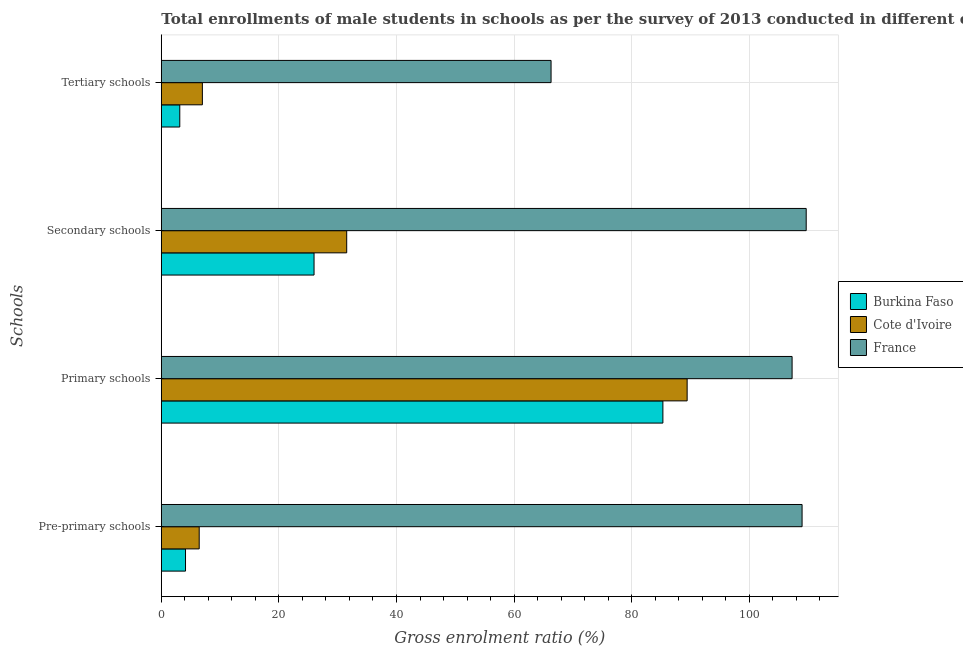Are the number of bars per tick equal to the number of legend labels?
Your answer should be compact. Yes. How many bars are there on the 3rd tick from the top?
Ensure brevity in your answer.  3. How many bars are there on the 2nd tick from the bottom?
Provide a succinct answer. 3. What is the label of the 1st group of bars from the top?
Provide a short and direct response. Tertiary schools. What is the gross enrolment ratio(male) in primary schools in France?
Keep it short and to the point. 107.29. Across all countries, what is the maximum gross enrolment ratio(male) in pre-primary schools?
Provide a short and direct response. 108.99. Across all countries, what is the minimum gross enrolment ratio(male) in primary schools?
Keep it short and to the point. 85.31. In which country was the gross enrolment ratio(male) in primary schools maximum?
Keep it short and to the point. France. In which country was the gross enrolment ratio(male) in tertiary schools minimum?
Keep it short and to the point. Burkina Faso. What is the total gross enrolment ratio(male) in primary schools in the graph?
Offer a terse response. 282.05. What is the difference between the gross enrolment ratio(male) in tertiary schools in France and that in Cote d'Ivoire?
Your answer should be very brief. 59.31. What is the difference between the gross enrolment ratio(male) in tertiary schools in Cote d'Ivoire and the gross enrolment ratio(male) in pre-primary schools in Burkina Faso?
Your answer should be compact. 2.87. What is the average gross enrolment ratio(male) in pre-primary schools per country?
Offer a terse response. 39.85. What is the difference between the gross enrolment ratio(male) in tertiary schools and gross enrolment ratio(male) in primary schools in Cote d'Ivoire?
Offer a terse response. -82.46. What is the ratio of the gross enrolment ratio(male) in tertiary schools in Cote d'Ivoire to that in France?
Provide a succinct answer. 0.11. Is the gross enrolment ratio(male) in tertiary schools in Burkina Faso less than that in France?
Offer a terse response. Yes. What is the difference between the highest and the second highest gross enrolment ratio(male) in primary schools?
Ensure brevity in your answer.  17.85. What is the difference between the highest and the lowest gross enrolment ratio(male) in tertiary schools?
Your answer should be very brief. 63.15. In how many countries, is the gross enrolment ratio(male) in secondary schools greater than the average gross enrolment ratio(male) in secondary schools taken over all countries?
Keep it short and to the point. 1. Is the sum of the gross enrolment ratio(male) in tertiary schools in Burkina Faso and France greater than the maximum gross enrolment ratio(male) in pre-primary schools across all countries?
Give a very brief answer. No. Is it the case that in every country, the sum of the gross enrolment ratio(male) in tertiary schools and gross enrolment ratio(male) in secondary schools is greater than the sum of gross enrolment ratio(male) in primary schools and gross enrolment ratio(male) in pre-primary schools?
Offer a very short reply. No. What does the 3rd bar from the top in Primary schools represents?
Your answer should be very brief. Burkina Faso. What does the 2nd bar from the bottom in Primary schools represents?
Provide a succinct answer. Cote d'Ivoire. Is it the case that in every country, the sum of the gross enrolment ratio(male) in pre-primary schools and gross enrolment ratio(male) in primary schools is greater than the gross enrolment ratio(male) in secondary schools?
Provide a succinct answer. Yes. How many bars are there?
Your answer should be very brief. 12. Are all the bars in the graph horizontal?
Offer a very short reply. Yes. How many countries are there in the graph?
Your answer should be compact. 3. What is the difference between two consecutive major ticks on the X-axis?
Your response must be concise. 20. Are the values on the major ticks of X-axis written in scientific E-notation?
Offer a terse response. No. Does the graph contain grids?
Provide a short and direct response. Yes. How are the legend labels stacked?
Provide a succinct answer. Vertical. What is the title of the graph?
Keep it short and to the point. Total enrollments of male students in schools as per the survey of 2013 conducted in different countries. What is the label or title of the X-axis?
Keep it short and to the point. Gross enrolment ratio (%). What is the label or title of the Y-axis?
Ensure brevity in your answer.  Schools. What is the Gross enrolment ratio (%) in Burkina Faso in Pre-primary schools?
Offer a terse response. 4.12. What is the Gross enrolment ratio (%) of Cote d'Ivoire in Pre-primary schools?
Provide a short and direct response. 6.44. What is the Gross enrolment ratio (%) of France in Pre-primary schools?
Give a very brief answer. 108.99. What is the Gross enrolment ratio (%) in Burkina Faso in Primary schools?
Provide a short and direct response. 85.31. What is the Gross enrolment ratio (%) of Cote d'Ivoire in Primary schools?
Make the answer very short. 89.44. What is the Gross enrolment ratio (%) of France in Primary schools?
Keep it short and to the point. 107.29. What is the Gross enrolment ratio (%) of Burkina Faso in Secondary schools?
Your response must be concise. 25.98. What is the Gross enrolment ratio (%) in Cote d'Ivoire in Secondary schools?
Provide a succinct answer. 31.53. What is the Gross enrolment ratio (%) in France in Secondary schools?
Make the answer very short. 109.69. What is the Gross enrolment ratio (%) in Burkina Faso in Tertiary schools?
Make the answer very short. 3.14. What is the Gross enrolment ratio (%) of Cote d'Ivoire in Tertiary schools?
Ensure brevity in your answer.  6.98. What is the Gross enrolment ratio (%) in France in Tertiary schools?
Offer a terse response. 66.3. Across all Schools, what is the maximum Gross enrolment ratio (%) of Burkina Faso?
Give a very brief answer. 85.31. Across all Schools, what is the maximum Gross enrolment ratio (%) in Cote d'Ivoire?
Make the answer very short. 89.44. Across all Schools, what is the maximum Gross enrolment ratio (%) in France?
Your answer should be very brief. 109.69. Across all Schools, what is the minimum Gross enrolment ratio (%) of Burkina Faso?
Keep it short and to the point. 3.14. Across all Schools, what is the minimum Gross enrolment ratio (%) of Cote d'Ivoire?
Offer a terse response. 6.44. Across all Schools, what is the minimum Gross enrolment ratio (%) in France?
Make the answer very short. 66.3. What is the total Gross enrolment ratio (%) in Burkina Faso in the graph?
Make the answer very short. 118.55. What is the total Gross enrolment ratio (%) of Cote d'Ivoire in the graph?
Your response must be concise. 134.4. What is the total Gross enrolment ratio (%) of France in the graph?
Give a very brief answer. 392.27. What is the difference between the Gross enrolment ratio (%) of Burkina Faso in Pre-primary schools and that in Primary schools?
Keep it short and to the point. -81.2. What is the difference between the Gross enrolment ratio (%) of Cote d'Ivoire in Pre-primary schools and that in Primary schools?
Provide a short and direct response. -83. What is the difference between the Gross enrolment ratio (%) of France in Pre-primary schools and that in Primary schools?
Provide a succinct answer. 1.7. What is the difference between the Gross enrolment ratio (%) of Burkina Faso in Pre-primary schools and that in Secondary schools?
Your response must be concise. -21.86. What is the difference between the Gross enrolment ratio (%) in Cote d'Ivoire in Pre-primary schools and that in Secondary schools?
Your response must be concise. -25.09. What is the difference between the Gross enrolment ratio (%) of France in Pre-primary schools and that in Secondary schools?
Your answer should be very brief. -0.7. What is the difference between the Gross enrolment ratio (%) of Burkina Faso in Pre-primary schools and that in Tertiary schools?
Make the answer very short. 0.98. What is the difference between the Gross enrolment ratio (%) of Cote d'Ivoire in Pre-primary schools and that in Tertiary schools?
Give a very brief answer. -0.54. What is the difference between the Gross enrolment ratio (%) in France in Pre-primary schools and that in Tertiary schools?
Keep it short and to the point. 42.7. What is the difference between the Gross enrolment ratio (%) in Burkina Faso in Primary schools and that in Secondary schools?
Give a very brief answer. 59.34. What is the difference between the Gross enrolment ratio (%) of Cote d'Ivoire in Primary schools and that in Secondary schools?
Your answer should be compact. 57.91. What is the difference between the Gross enrolment ratio (%) in France in Primary schools and that in Secondary schools?
Make the answer very short. -2.4. What is the difference between the Gross enrolment ratio (%) in Burkina Faso in Primary schools and that in Tertiary schools?
Keep it short and to the point. 82.17. What is the difference between the Gross enrolment ratio (%) of Cote d'Ivoire in Primary schools and that in Tertiary schools?
Provide a succinct answer. 82.46. What is the difference between the Gross enrolment ratio (%) of France in Primary schools and that in Tertiary schools?
Your answer should be compact. 41. What is the difference between the Gross enrolment ratio (%) in Burkina Faso in Secondary schools and that in Tertiary schools?
Make the answer very short. 22.84. What is the difference between the Gross enrolment ratio (%) in Cote d'Ivoire in Secondary schools and that in Tertiary schools?
Ensure brevity in your answer.  24.55. What is the difference between the Gross enrolment ratio (%) of France in Secondary schools and that in Tertiary schools?
Provide a succinct answer. 43.4. What is the difference between the Gross enrolment ratio (%) of Burkina Faso in Pre-primary schools and the Gross enrolment ratio (%) of Cote d'Ivoire in Primary schools?
Give a very brief answer. -85.33. What is the difference between the Gross enrolment ratio (%) of Burkina Faso in Pre-primary schools and the Gross enrolment ratio (%) of France in Primary schools?
Provide a short and direct response. -103.18. What is the difference between the Gross enrolment ratio (%) of Cote d'Ivoire in Pre-primary schools and the Gross enrolment ratio (%) of France in Primary schools?
Your answer should be compact. -100.85. What is the difference between the Gross enrolment ratio (%) in Burkina Faso in Pre-primary schools and the Gross enrolment ratio (%) in Cote d'Ivoire in Secondary schools?
Offer a terse response. -27.42. What is the difference between the Gross enrolment ratio (%) of Burkina Faso in Pre-primary schools and the Gross enrolment ratio (%) of France in Secondary schools?
Offer a very short reply. -105.58. What is the difference between the Gross enrolment ratio (%) in Cote d'Ivoire in Pre-primary schools and the Gross enrolment ratio (%) in France in Secondary schools?
Provide a succinct answer. -103.25. What is the difference between the Gross enrolment ratio (%) of Burkina Faso in Pre-primary schools and the Gross enrolment ratio (%) of Cote d'Ivoire in Tertiary schools?
Your answer should be very brief. -2.87. What is the difference between the Gross enrolment ratio (%) of Burkina Faso in Pre-primary schools and the Gross enrolment ratio (%) of France in Tertiary schools?
Give a very brief answer. -62.18. What is the difference between the Gross enrolment ratio (%) of Cote d'Ivoire in Pre-primary schools and the Gross enrolment ratio (%) of France in Tertiary schools?
Your answer should be compact. -59.85. What is the difference between the Gross enrolment ratio (%) of Burkina Faso in Primary schools and the Gross enrolment ratio (%) of Cote d'Ivoire in Secondary schools?
Keep it short and to the point. 53.78. What is the difference between the Gross enrolment ratio (%) in Burkina Faso in Primary schools and the Gross enrolment ratio (%) in France in Secondary schools?
Keep it short and to the point. -24.38. What is the difference between the Gross enrolment ratio (%) of Cote d'Ivoire in Primary schools and the Gross enrolment ratio (%) of France in Secondary schools?
Give a very brief answer. -20.25. What is the difference between the Gross enrolment ratio (%) in Burkina Faso in Primary schools and the Gross enrolment ratio (%) in Cote d'Ivoire in Tertiary schools?
Keep it short and to the point. 78.33. What is the difference between the Gross enrolment ratio (%) in Burkina Faso in Primary schools and the Gross enrolment ratio (%) in France in Tertiary schools?
Keep it short and to the point. 19.02. What is the difference between the Gross enrolment ratio (%) in Cote d'Ivoire in Primary schools and the Gross enrolment ratio (%) in France in Tertiary schools?
Your answer should be compact. 23.15. What is the difference between the Gross enrolment ratio (%) of Burkina Faso in Secondary schools and the Gross enrolment ratio (%) of Cote d'Ivoire in Tertiary schools?
Provide a short and direct response. 18.99. What is the difference between the Gross enrolment ratio (%) of Burkina Faso in Secondary schools and the Gross enrolment ratio (%) of France in Tertiary schools?
Make the answer very short. -40.32. What is the difference between the Gross enrolment ratio (%) in Cote d'Ivoire in Secondary schools and the Gross enrolment ratio (%) in France in Tertiary schools?
Ensure brevity in your answer.  -34.76. What is the average Gross enrolment ratio (%) in Burkina Faso per Schools?
Keep it short and to the point. 29.64. What is the average Gross enrolment ratio (%) of Cote d'Ivoire per Schools?
Make the answer very short. 33.6. What is the average Gross enrolment ratio (%) in France per Schools?
Give a very brief answer. 98.07. What is the difference between the Gross enrolment ratio (%) in Burkina Faso and Gross enrolment ratio (%) in Cote d'Ivoire in Pre-primary schools?
Give a very brief answer. -2.33. What is the difference between the Gross enrolment ratio (%) in Burkina Faso and Gross enrolment ratio (%) in France in Pre-primary schools?
Offer a terse response. -104.88. What is the difference between the Gross enrolment ratio (%) of Cote d'Ivoire and Gross enrolment ratio (%) of France in Pre-primary schools?
Keep it short and to the point. -102.55. What is the difference between the Gross enrolment ratio (%) in Burkina Faso and Gross enrolment ratio (%) in Cote d'Ivoire in Primary schools?
Make the answer very short. -4.13. What is the difference between the Gross enrolment ratio (%) of Burkina Faso and Gross enrolment ratio (%) of France in Primary schools?
Keep it short and to the point. -21.98. What is the difference between the Gross enrolment ratio (%) in Cote d'Ivoire and Gross enrolment ratio (%) in France in Primary schools?
Ensure brevity in your answer.  -17.85. What is the difference between the Gross enrolment ratio (%) of Burkina Faso and Gross enrolment ratio (%) of Cote d'Ivoire in Secondary schools?
Give a very brief answer. -5.56. What is the difference between the Gross enrolment ratio (%) of Burkina Faso and Gross enrolment ratio (%) of France in Secondary schools?
Provide a short and direct response. -83.71. What is the difference between the Gross enrolment ratio (%) of Cote d'Ivoire and Gross enrolment ratio (%) of France in Secondary schools?
Your answer should be very brief. -78.16. What is the difference between the Gross enrolment ratio (%) in Burkina Faso and Gross enrolment ratio (%) in Cote d'Ivoire in Tertiary schools?
Ensure brevity in your answer.  -3.84. What is the difference between the Gross enrolment ratio (%) of Burkina Faso and Gross enrolment ratio (%) of France in Tertiary schools?
Keep it short and to the point. -63.15. What is the difference between the Gross enrolment ratio (%) in Cote d'Ivoire and Gross enrolment ratio (%) in France in Tertiary schools?
Provide a short and direct response. -59.31. What is the ratio of the Gross enrolment ratio (%) of Burkina Faso in Pre-primary schools to that in Primary schools?
Your answer should be compact. 0.05. What is the ratio of the Gross enrolment ratio (%) in Cote d'Ivoire in Pre-primary schools to that in Primary schools?
Keep it short and to the point. 0.07. What is the ratio of the Gross enrolment ratio (%) in France in Pre-primary schools to that in Primary schools?
Make the answer very short. 1.02. What is the ratio of the Gross enrolment ratio (%) of Burkina Faso in Pre-primary schools to that in Secondary schools?
Give a very brief answer. 0.16. What is the ratio of the Gross enrolment ratio (%) of Cote d'Ivoire in Pre-primary schools to that in Secondary schools?
Provide a short and direct response. 0.2. What is the ratio of the Gross enrolment ratio (%) of France in Pre-primary schools to that in Secondary schools?
Keep it short and to the point. 0.99. What is the ratio of the Gross enrolment ratio (%) in Burkina Faso in Pre-primary schools to that in Tertiary schools?
Offer a very short reply. 1.31. What is the ratio of the Gross enrolment ratio (%) in Cote d'Ivoire in Pre-primary schools to that in Tertiary schools?
Make the answer very short. 0.92. What is the ratio of the Gross enrolment ratio (%) in France in Pre-primary schools to that in Tertiary schools?
Provide a short and direct response. 1.64. What is the ratio of the Gross enrolment ratio (%) in Burkina Faso in Primary schools to that in Secondary schools?
Provide a short and direct response. 3.28. What is the ratio of the Gross enrolment ratio (%) of Cote d'Ivoire in Primary schools to that in Secondary schools?
Give a very brief answer. 2.84. What is the ratio of the Gross enrolment ratio (%) of France in Primary schools to that in Secondary schools?
Your answer should be very brief. 0.98. What is the ratio of the Gross enrolment ratio (%) of Burkina Faso in Primary schools to that in Tertiary schools?
Offer a very short reply. 27.16. What is the ratio of the Gross enrolment ratio (%) in Cote d'Ivoire in Primary schools to that in Tertiary schools?
Provide a succinct answer. 12.81. What is the ratio of the Gross enrolment ratio (%) in France in Primary schools to that in Tertiary schools?
Give a very brief answer. 1.62. What is the ratio of the Gross enrolment ratio (%) of Burkina Faso in Secondary schools to that in Tertiary schools?
Your answer should be compact. 8.27. What is the ratio of the Gross enrolment ratio (%) of Cote d'Ivoire in Secondary schools to that in Tertiary schools?
Provide a short and direct response. 4.52. What is the ratio of the Gross enrolment ratio (%) in France in Secondary schools to that in Tertiary schools?
Give a very brief answer. 1.65. What is the difference between the highest and the second highest Gross enrolment ratio (%) in Burkina Faso?
Make the answer very short. 59.34. What is the difference between the highest and the second highest Gross enrolment ratio (%) in Cote d'Ivoire?
Provide a short and direct response. 57.91. What is the difference between the highest and the second highest Gross enrolment ratio (%) of France?
Ensure brevity in your answer.  0.7. What is the difference between the highest and the lowest Gross enrolment ratio (%) of Burkina Faso?
Your response must be concise. 82.17. What is the difference between the highest and the lowest Gross enrolment ratio (%) in Cote d'Ivoire?
Give a very brief answer. 83. What is the difference between the highest and the lowest Gross enrolment ratio (%) in France?
Give a very brief answer. 43.4. 